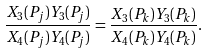<formula> <loc_0><loc_0><loc_500><loc_500>\frac { X _ { 3 } ( P _ { j } ) Y _ { 3 } ( P _ { j } ) } { X _ { 4 } ( P _ { j } ) Y _ { 4 } ( P _ { j } ) } = \frac { X _ { 3 } ( P _ { k } ) Y _ { 3 } ( P _ { k } ) } { X _ { 4 } ( P _ { k } ) Y _ { 4 } ( P _ { k } ) } .</formula> 